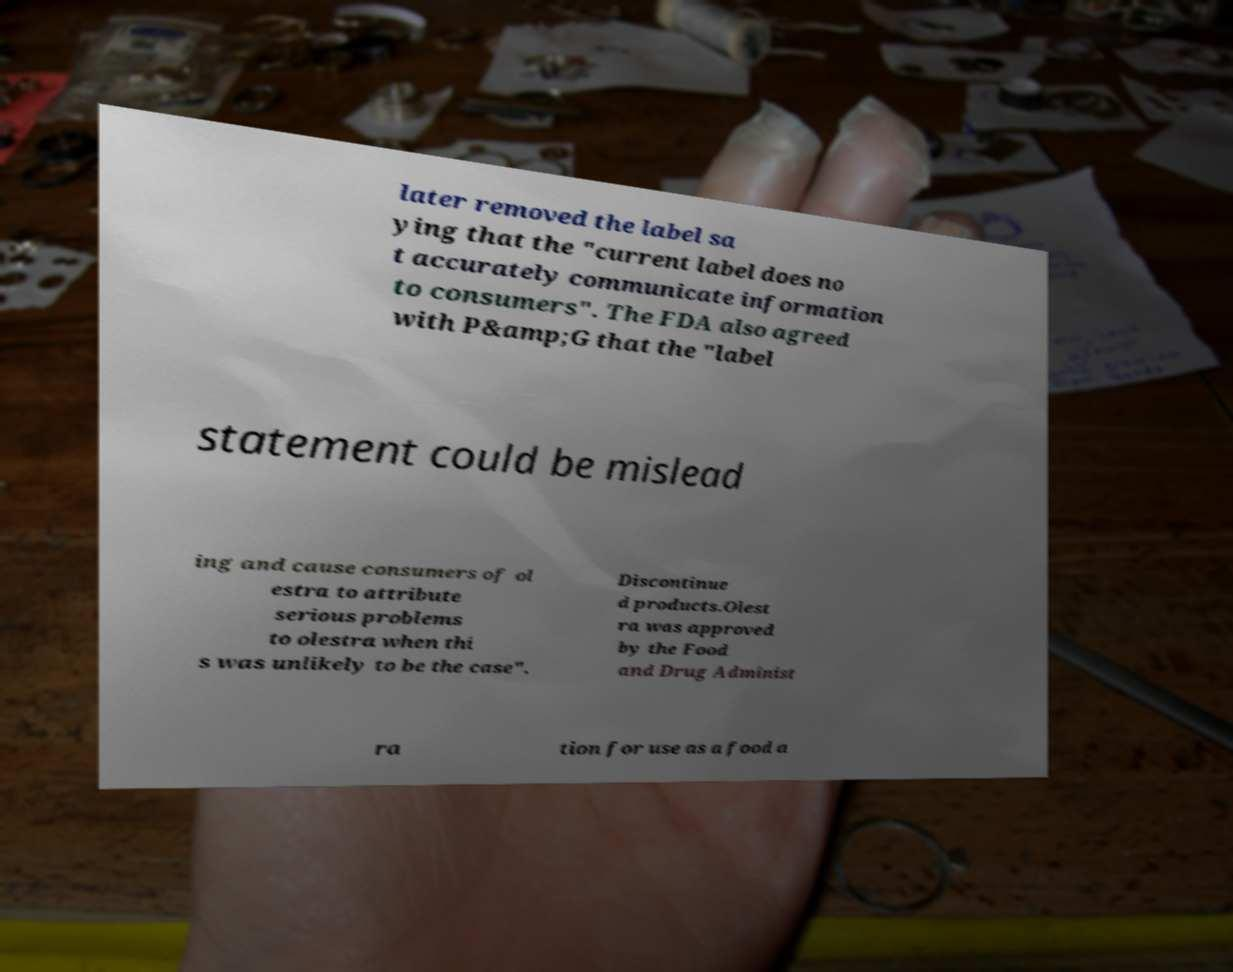For documentation purposes, I need the text within this image transcribed. Could you provide that? later removed the label sa ying that the "current label does no t accurately communicate information to consumers". The FDA also agreed with P&amp;G that the "label statement could be mislead ing and cause consumers of ol estra to attribute serious problems to olestra when thi s was unlikely to be the case". Discontinue d products.Olest ra was approved by the Food and Drug Administ ra tion for use as a food a 